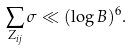Convert formula to latex. <formula><loc_0><loc_0><loc_500><loc_500>\sum _ { Z _ { i j } } \sigma \ll ( \log B ) ^ { 6 } .</formula> 